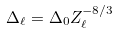<formula> <loc_0><loc_0><loc_500><loc_500>\Delta _ { \ell } = \Delta _ { 0 } Z ^ { - 8 / 3 } _ { \ell }</formula> 